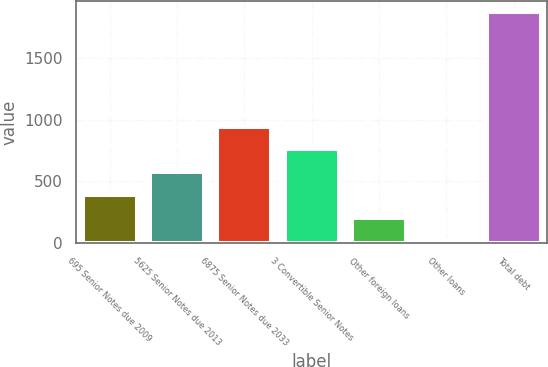Convert chart. <chart><loc_0><loc_0><loc_500><loc_500><bar_chart><fcel>695 Senior Notes due 2009<fcel>5625 Senior Notes due 2013<fcel>6875 Senior Notes due 2033<fcel>3 Convertible Senior Notes<fcel>Other foreign loans<fcel>Other loans<fcel>Total debt<nl><fcel>389.4<fcel>574.7<fcel>945.3<fcel>760<fcel>204.1<fcel>18.8<fcel>1871.8<nl></chart> 